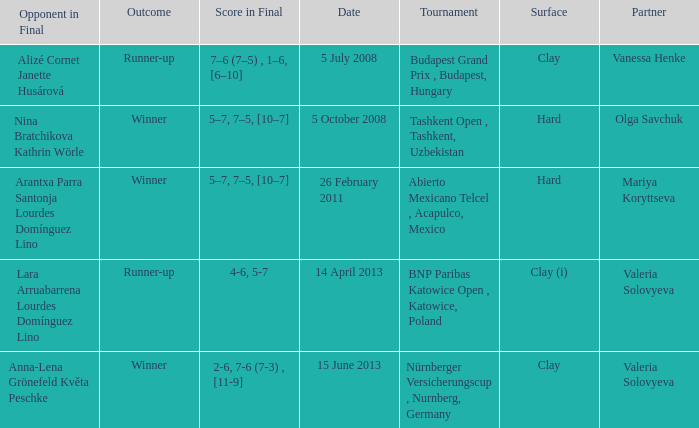Name the outcome that had an opponent in final of nina bratchikova kathrin wörle Winner. Could you parse the entire table as a dict? {'header': ['Opponent in Final', 'Outcome', 'Score in Final', 'Date', 'Tournament', 'Surface', 'Partner'], 'rows': [['Alizé Cornet Janette Husárová', 'Runner-up', '7–6 (7–5) , 1–6, [6–10]', '5 July 2008', 'Budapest Grand Prix , Budapest, Hungary', 'Clay', 'Vanessa Henke'], ['Nina Bratchikova Kathrin Wörle', 'Winner', '5–7, 7–5, [10–7]', '5 October 2008', 'Tashkent Open , Tashkent, Uzbekistan', 'Hard', 'Olga Savchuk'], ['Arantxa Parra Santonja Lourdes Domínguez Lino', 'Winner', '5–7, 7–5, [10–7]', '26 February 2011', 'Abierto Mexicano Telcel , Acapulco, Mexico', 'Hard', 'Mariya Koryttseva'], ['Lara Arruabarrena Lourdes Domínguez Lino', 'Runner-up', '4-6, 5-7', '14 April 2013', 'BNP Paribas Katowice Open , Katowice, Poland', 'Clay (i)', 'Valeria Solovyeva'], ['Anna-Lena Grönefeld Květa Peschke', 'Winner', '2-6, 7-6 (7-3) , [11-9]', '15 June 2013', 'Nürnberger Versicherungscup , Nurnberg, Germany', 'Clay', 'Valeria Solovyeva']]} 